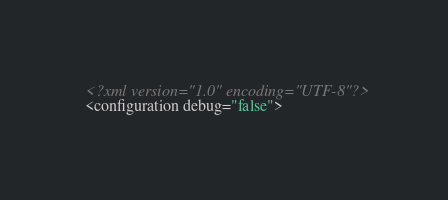Convert code to text. <code><loc_0><loc_0><loc_500><loc_500><_XML_><?xml version="1.0" encoding="UTF-8"?>
<configuration debug="false">
</code> 